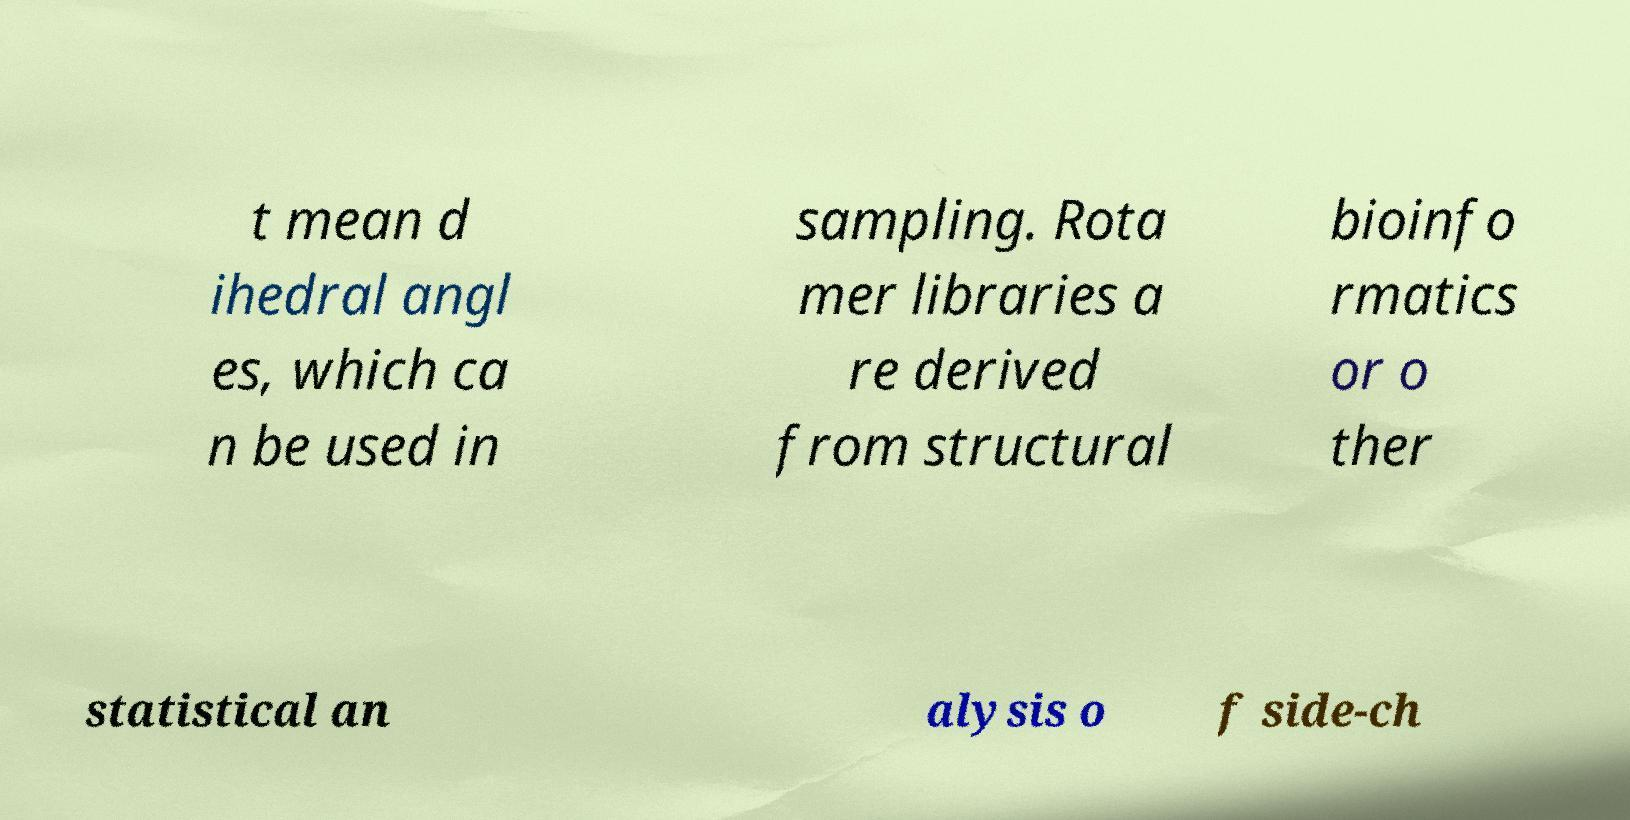Could you assist in decoding the text presented in this image and type it out clearly? t mean d ihedral angl es, which ca n be used in sampling. Rota mer libraries a re derived from structural bioinfo rmatics or o ther statistical an alysis o f side-ch 